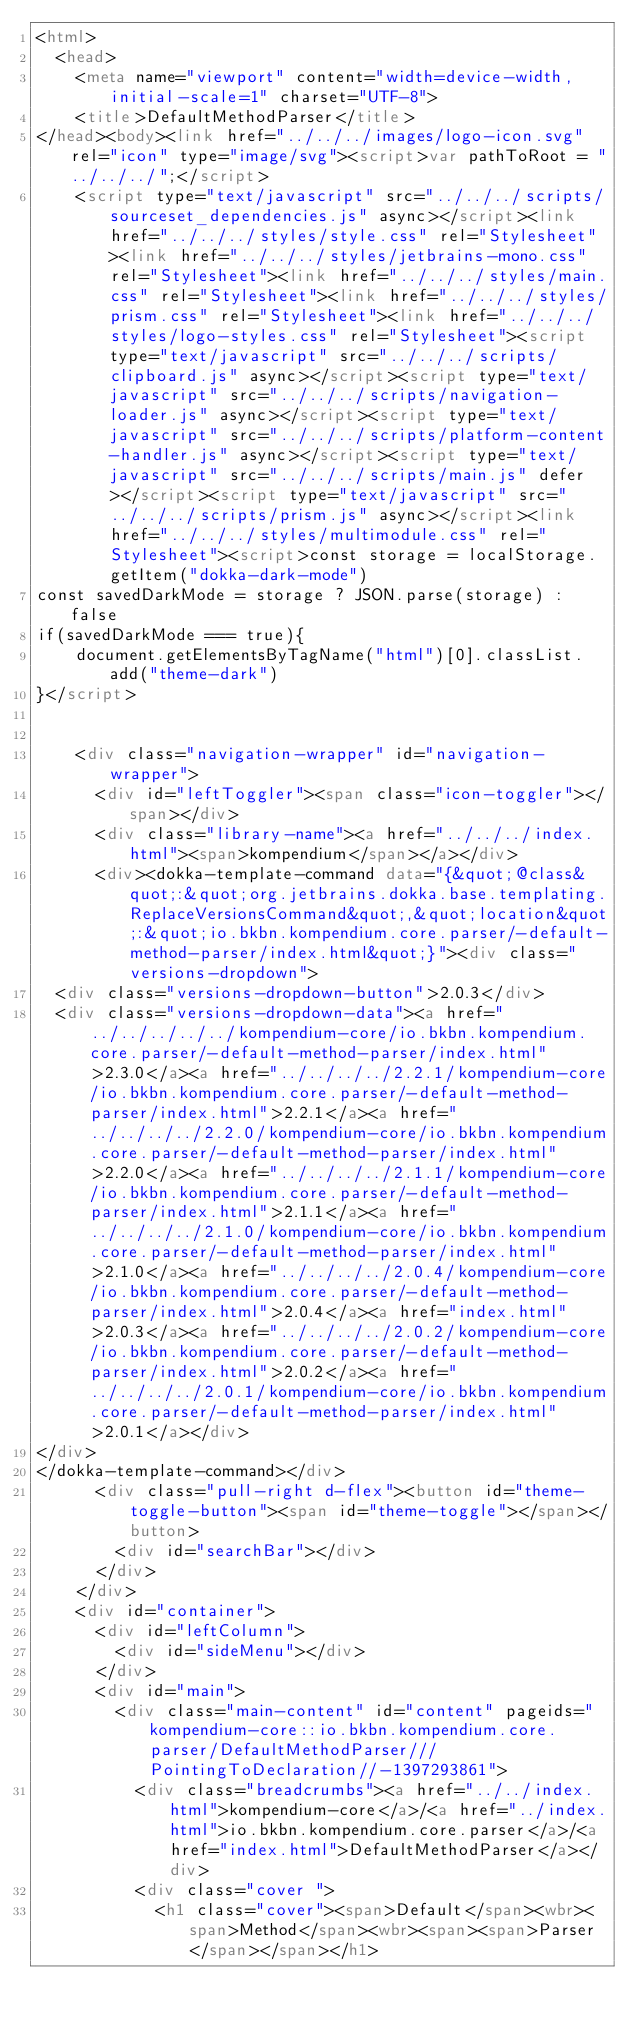<code> <loc_0><loc_0><loc_500><loc_500><_HTML_><html>
  <head>
    <meta name="viewport" content="width=device-width, initial-scale=1" charset="UTF-8">
    <title>DefaultMethodParser</title>
</head><body><link href="../../../images/logo-icon.svg" rel="icon" type="image/svg"><script>var pathToRoot = "../../../";</script>
    <script type="text/javascript" src="../../../scripts/sourceset_dependencies.js" async></script><link href="../../../styles/style.css" rel="Stylesheet"><link href="../../../styles/jetbrains-mono.css" rel="Stylesheet"><link href="../../../styles/main.css" rel="Stylesheet"><link href="../../../styles/prism.css" rel="Stylesheet"><link href="../../../styles/logo-styles.css" rel="Stylesheet"><script type="text/javascript" src="../../../scripts/clipboard.js" async></script><script type="text/javascript" src="../../../scripts/navigation-loader.js" async></script><script type="text/javascript" src="../../../scripts/platform-content-handler.js" async></script><script type="text/javascript" src="../../../scripts/main.js" defer></script><script type="text/javascript" src="../../../scripts/prism.js" async></script><link href="../../../styles/multimodule.css" rel="Stylesheet"><script>const storage = localStorage.getItem("dokka-dark-mode")
const savedDarkMode = storage ? JSON.parse(storage) : false
if(savedDarkMode === true){
    document.getElementsByTagName("html")[0].classList.add("theme-dark")
}</script>

  
    <div class="navigation-wrapper" id="navigation-wrapper">
      <div id="leftToggler"><span class="icon-toggler"></span></div>
      <div class="library-name"><a href="../../../index.html"><span>kompendium</span></a></div>
      <div><dokka-template-command data="{&quot;@class&quot;:&quot;org.jetbrains.dokka.base.templating.ReplaceVersionsCommand&quot;,&quot;location&quot;:&quot;io.bkbn.kompendium.core.parser/-default-method-parser/index.html&quot;}"><div class="versions-dropdown">
  <div class="versions-dropdown-button">2.0.3</div>
  <div class="versions-dropdown-data"><a href="../../../../../kompendium-core/io.bkbn.kompendium.core.parser/-default-method-parser/index.html">2.3.0</a><a href="../../../../2.2.1/kompendium-core/io.bkbn.kompendium.core.parser/-default-method-parser/index.html">2.2.1</a><a href="../../../../2.2.0/kompendium-core/io.bkbn.kompendium.core.parser/-default-method-parser/index.html">2.2.0</a><a href="../../../../2.1.1/kompendium-core/io.bkbn.kompendium.core.parser/-default-method-parser/index.html">2.1.1</a><a href="../../../../2.1.0/kompendium-core/io.bkbn.kompendium.core.parser/-default-method-parser/index.html">2.1.0</a><a href="../../../../2.0.4/kompendium-core/io.bkbn.kompendium.core.parser/-default-method-parser/index.html">2.0.4</a><a href="index.html">2.0.3</a><a href="../../../../2.0.2/kompendium-core/io.bkbn.kompendium.core.parser/-default-method-parser/index.html">2.0.2</a><a href="../../../../2.0.1/kompendium-core/io.bkbn.kompendium.core.parser/-default-method-parser/index.html">2.0.1</a></div>
</div>
</dokka-template-command></div>
      <div class="pull-right d-flex"><button id="theme-toggle-button"><span id="theme-toggle"></span></button>
        <div id="searchBar"></div>
      </div>
    </div>
    <div id="container">
      <div id="leftColumn">
        <div id="sideMenu"></div>
      </div>
      <div id="main">
        <div class="main-content" id="content" pageids="kompendium-core::io.bkbn.kompendium.core.parser/DefaultMethodParser///PointingToDeclaration//-1397293861">
          <div class="breadcrumbs"><a href="../../index.html">kompendium-core</a>/<a href="../index.html">io.bkbn.kompendium.core.parser</a>/<a href="index.html">DefaultMethodParser</a></div>
          <div class="cover ">
            <h1 class="cover"><span>Default</span><wbr><span>Method</span><wbr><span><span>Parser</span></span></h1></code> 